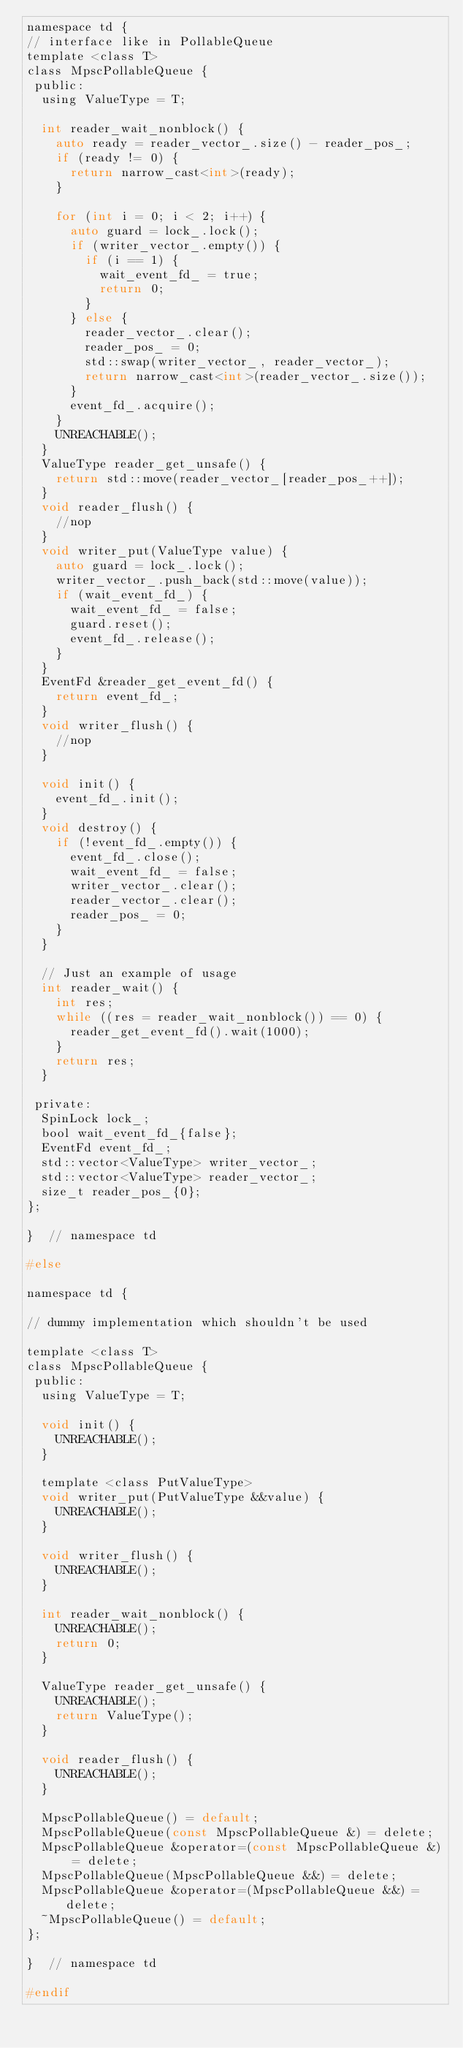Convert code to text. <code><loc_0><loc_0><loc_500><loc_500><_C_>namespace td {
// interface like in PollableQueue
template <class T>
class MpscPollableQueue {
 public:
  using ValueType = T;

  int reader_wait_nonblock() {
    auto ready = reader_vector_.size() - reader_pos_;
    if (ready != 0) {
      return narrow_cast<int>(ready);
    }

    for (int i = 0; i < 2; i++) {
      auto guard = lock_.lock();
      if (writer_vector_.empty()) {
        if (i == 1) {
          wait_event_fd_ = true;
          return 0;
        }
      } else {
        reader_vector_.clear();
        reader_pos_ = 0;
        std::swap(writer_vector_, reader_vector_);
        return narrow_cast<int>(reader_vector_.size());
      }
      event_fd_.acquire();
    }
    UNREACHABLE();
  }
  ValueType reader_get_unsafe() {
    return std::move(reader_vector_[reader_pos_++]);
  }
  void reader_flush() {
    //nop
  }
  void writer_put(ValueType value) {
    auto guard = lock_.lock();
    writer_vector_.push_back(std::move(value));
    if (wait_event_fd_) {
      wait_event_fd_ = false;
      guard.reset();
      event_fd_.release();
    }
  }
  EventFd &reader_get_event_fd() {
    return event_fd_;
  }
  void writer_flush() {
    //nop
  }

  void init() {
    event_fd_.init();
  }
  void destroy() {
    if (!event_fd_.empty()) {
      event_fd_.close();
      wait_event_fd_ = false;
      writer_vector_.clear();
      reader_vector_.clear();
      reader_pos_ = 0;
    }
  }

  // Just an example of usage
  int reader_wait() {
    int res;
    while ((res = reader_wait_nonblock()) == 0) {
      reader_get_event_fd().wait(1000);
    }
    return res;
  }

 private:
  SpinLock lock_;
  bool wait_event_fd_{false};
  EventFd event_fd_;
  std::vector<ValueType> writer_vector_;
  std::vector<ValueType> reader_vector_;
  size_t reader_pos_{0};
};

}  // namespace td

#else

namespace td {

// dummy implementation which shouldn't be used

template <class T>
class MpscPollableQueue {
 public:
  using ValueType = T;

  void init() {
    UNREACHABLE();
  }

  template <class PutValueType>
  void writer_put(PutValueType &&value) {
    UNREACHABLE();
  }

  void writer_flush() {
    UNREACHABLE();
  }

  int reader_wait_nonblock() {
    UNREACHABLE();
    return 0;
  }

  ValueType reader_get_unsafe() {
    UNREACHABLE();
    return ValueType();
  }

  void reader_flush() {
    UNREACHABLE();
  }

  MpscPollableQueue() = default;
  MpscPollableQueue(const MpscPollableQueue &) = delete;
  MpscPollableQueue &operator=(const MpscPollableQueue &) = delete;
  MpscPollableQueue(MpscPollableQueue &&) = delete;
  MpscPollableQueue &operator=(MpscPollableQueue &&) = delete;
  ~MpscPollableQueue() = default;
};

}  // namespace td

#endif
</code> 